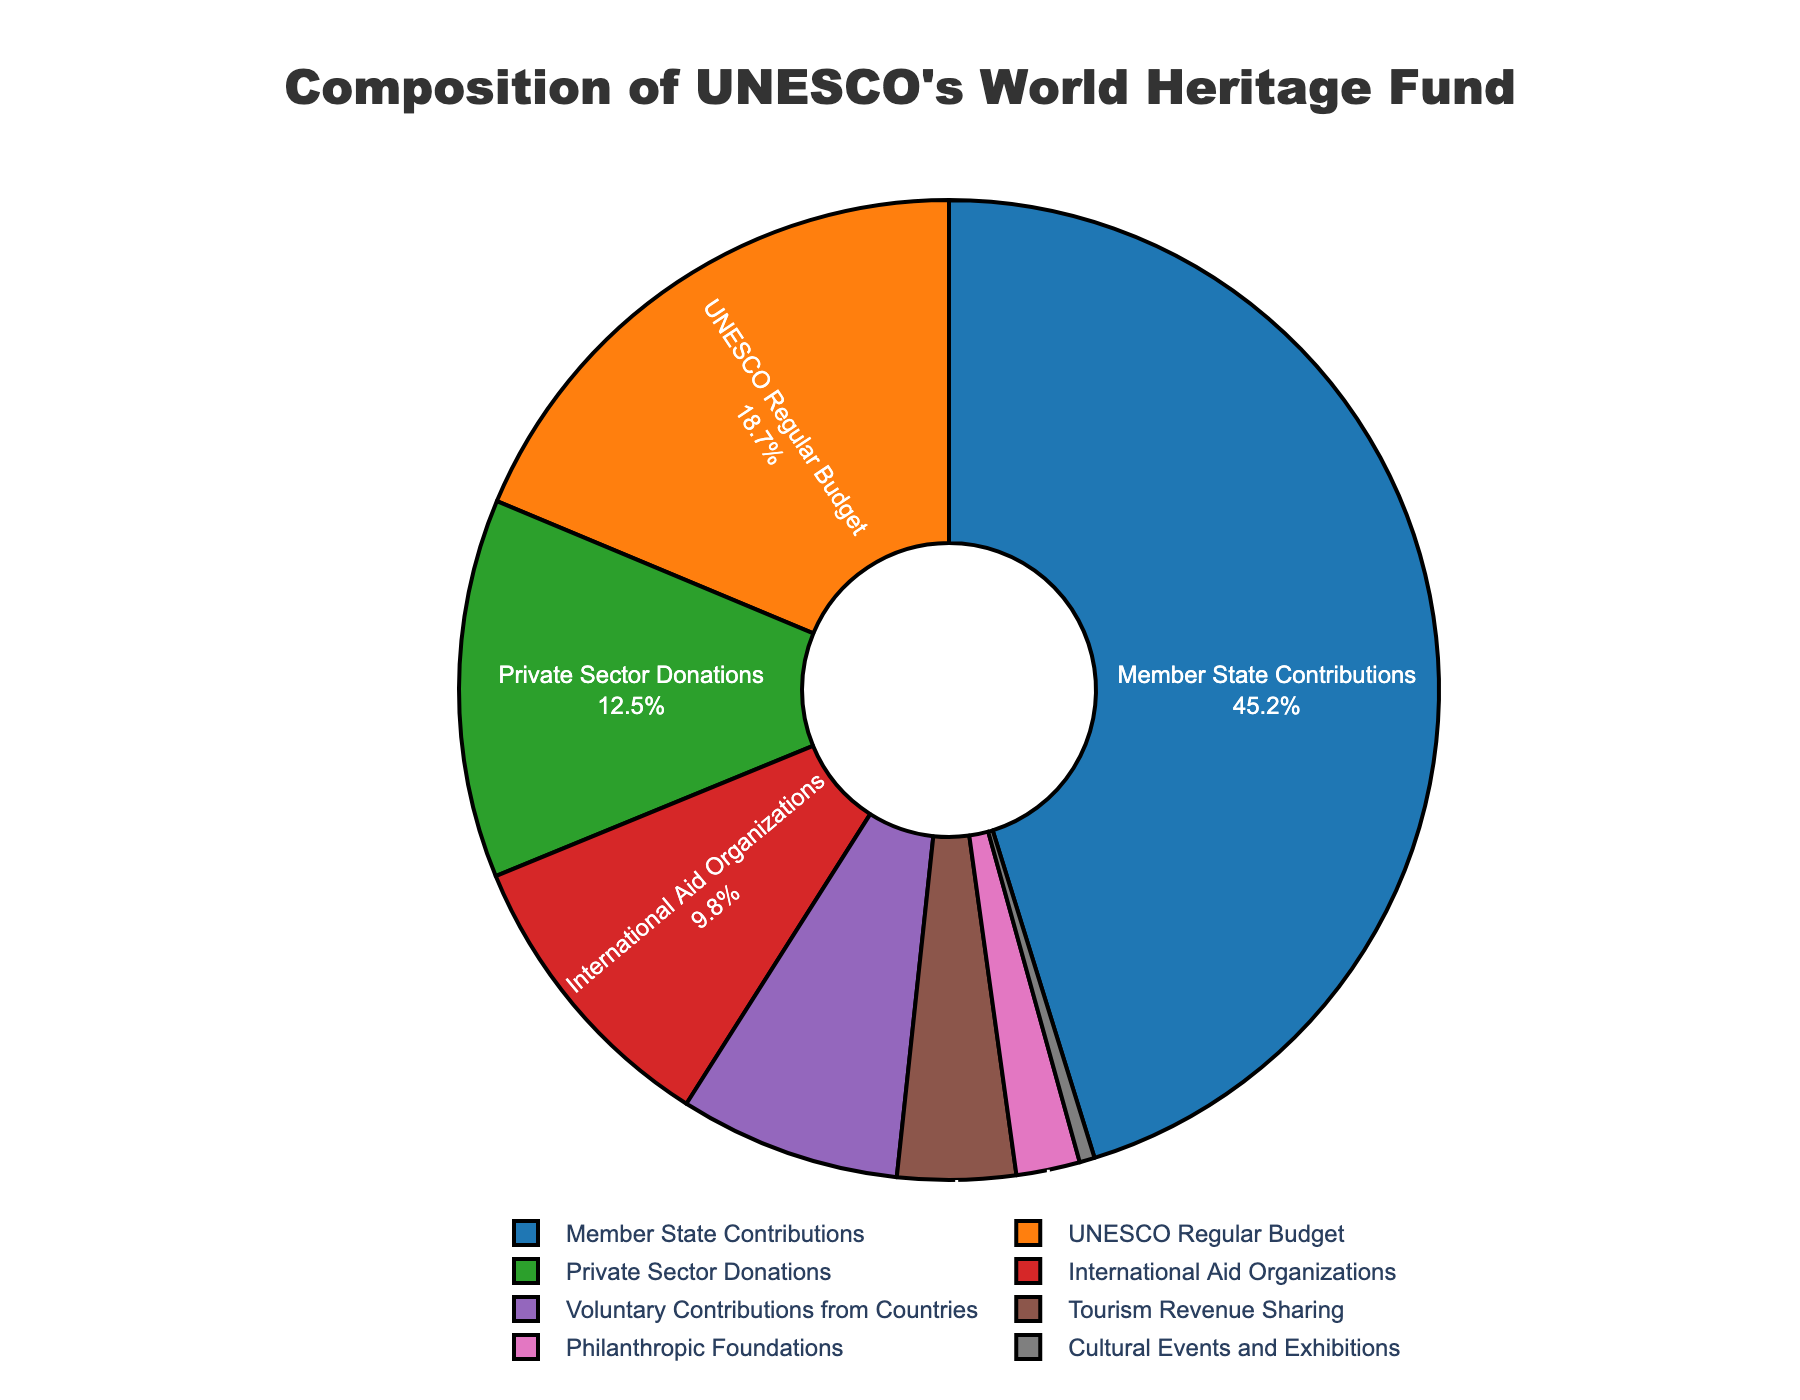What is the largest funding source for UNESCO's World Heritage Fund? Look at the slice of the pie chart with the largest percentage label; it is "Member State Contributions" at 45.2%.
Answer: Member State Contributions What percentage of the World Heritage Fund comes from UNESCO's Regular Budget and Voluntary Contributions from Countries combined? Locate the percentages for "UNESCO Regular Budget" (18.7%) and "Voluntary Contributions from Countries" (7.3%), and sum them: 18.7 + 7.3 = 26%.
Answer: 26% Which funding source contributes less than 1% to the World Heritage Fund? Identify the slice with a percentage less than 1%; it is "Cultural Events and Exhibitions" at 0.5%.
Answer: Cultural Events and Exhibitions How much more does the largest funding source contribute compared to the smallest funding source? Subtract the smallest percentage from the largest percentage: 45.2% (Member State Contributions) - 0.5% (Cultural Events and Exhibitions) = 44.7%.
Answer: 44.7% Which funding source contributes more: Private Sector Donations or Tourism Revenue Sharing? Compare the percentages of "Private Sector Donations" (12.5%) and "Tourism Revenue Sharing" (3.9%). Private Sector Donations is higher.
Answer: Private Sector Donations What percentage of the funding comes from sources other than Member State Contributions and UNESCO Regular Budget? Find the total percentage for all sources, then subtract the percentages of "Member State Contributions" (45.2%) and "UNESCO Regular Budget" (18.7%): 100% - (45.2% + 18.7%) = 36.1%.
Answer: 36.1% How does the contribution of International Aid Organizations compare to Philanthropic Foundations? Compare the percentages of "International Aid Organizations" (9.8%) and "Philanthropic Foundations" (2.1%). International Aid Organizations contribute more.
Answer: International Aid Organizations 